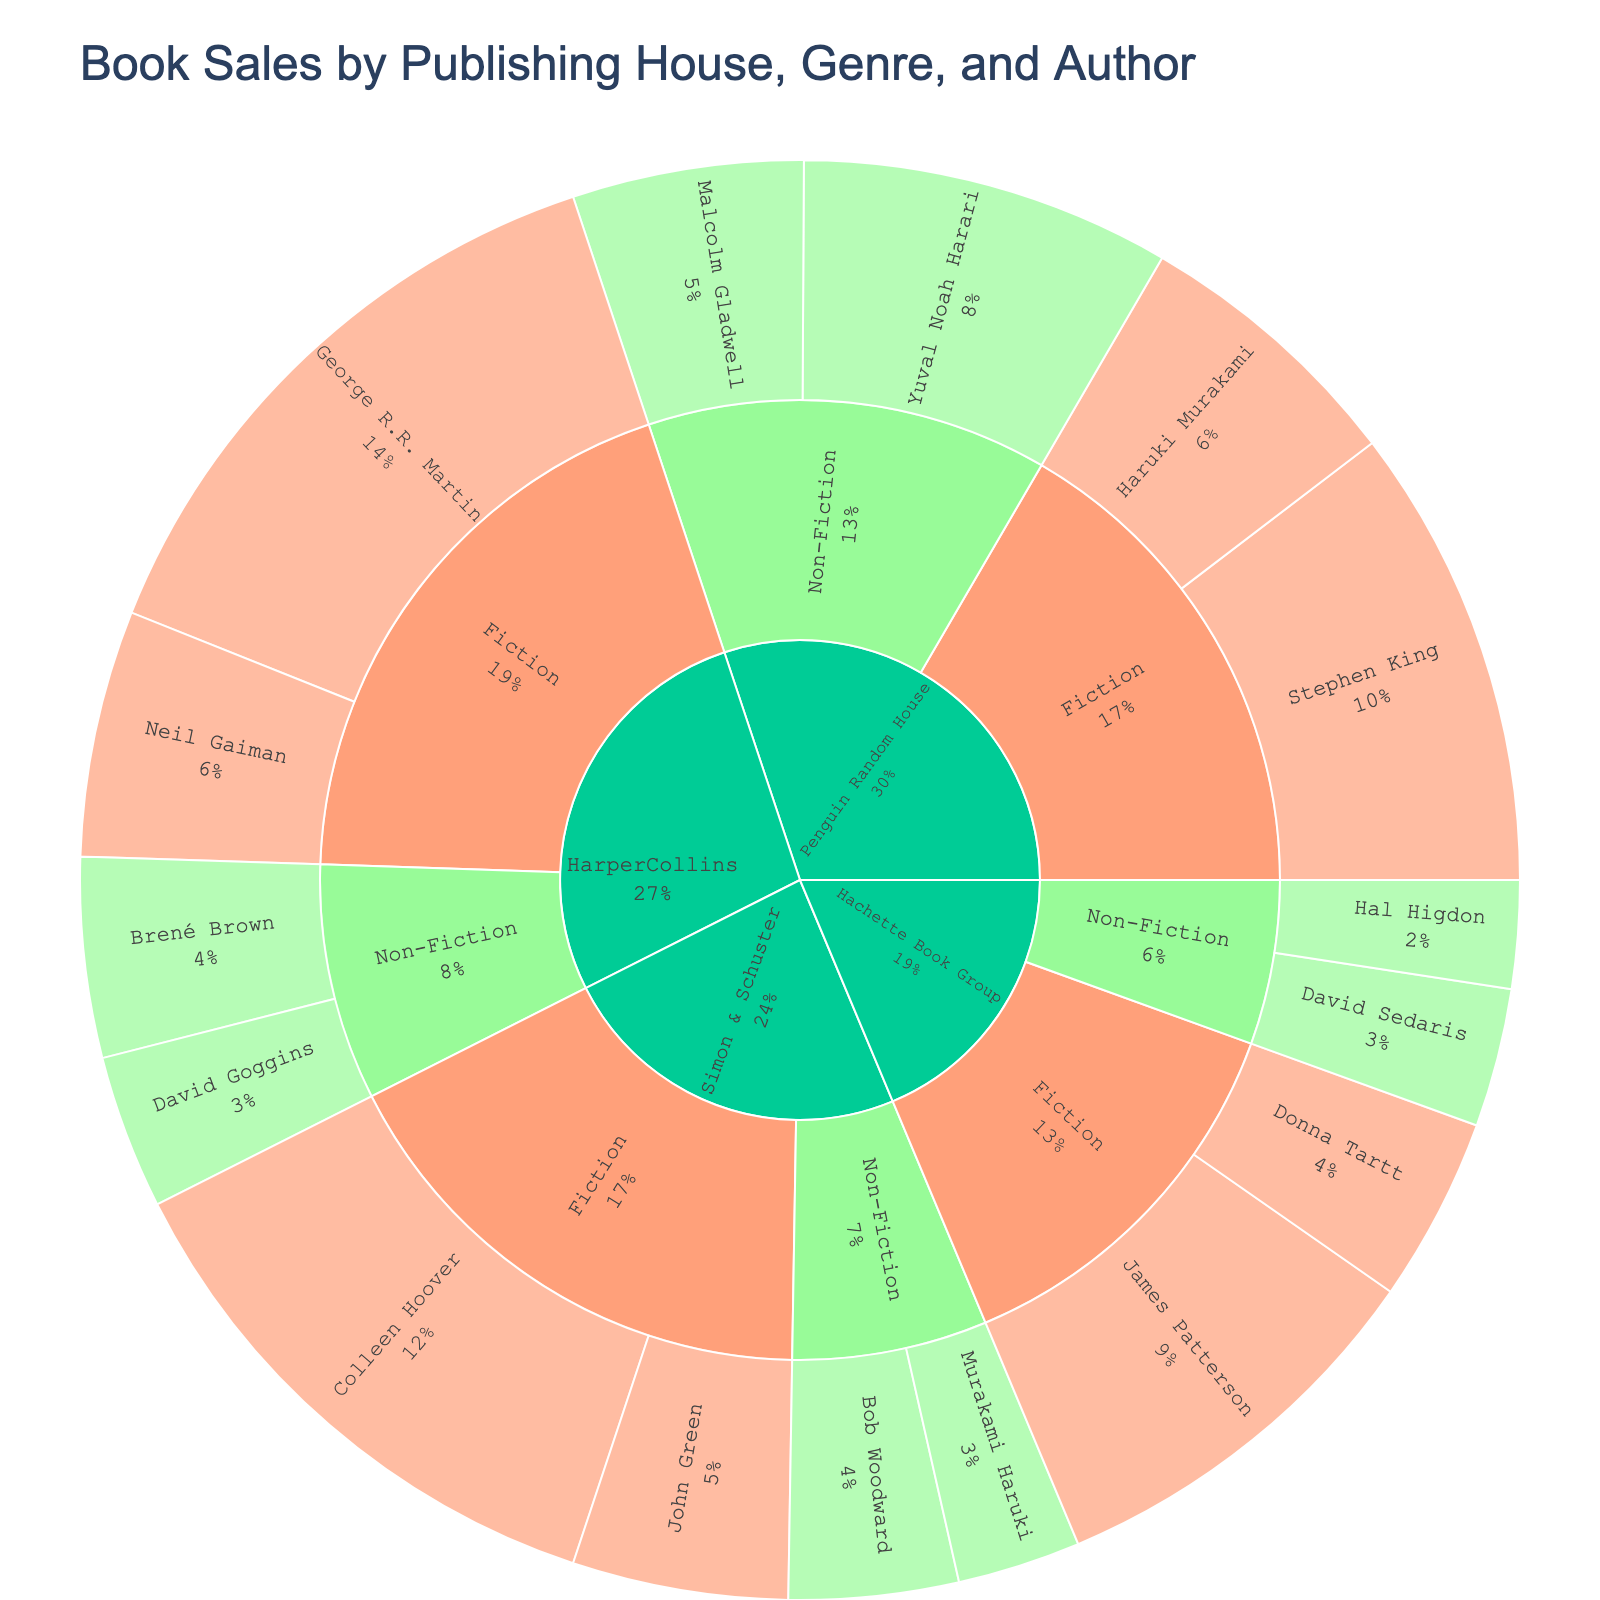**Q1:** What is the overall title of the Sunburst plot? The overall title of the Sunburst plot is directly stated at the top of the figure, indicating the main topic or focus.
Answer: Book Sales by Publishing House, Genre, and Author **Q2:** Which genre has the higher total sales, Fiction or Non-Fiction? To determine the genre with higher total sales, sum the sales of all corresponding authors for both Fiction and Non-Fiction and compare the totals.
Answer: Fiction **Q3:** Which author has the highest book sales? To find the highest selling author, look for the segment representing the author with the largest sales value.
Answer: George R.R. Martin **Q4:** How much is the difference in book sales between Stephen King and Yuval Noah Harari? Find the sales of Stephen King and Yuval Noah Harari, then subtract the smaller value from the larger one to get the difference. Stephen King's sales are 1500000 and Yuval Noah Harari's are 1200000.
Answer: 300000 **Q5:** What are the total sales for Penguin Random House? Sum the sales of all authors under Penguin Random House. Stephen King (1500000) + Haruki Murakami (900000) + Malcolm Gladwell (750000) + Yuval Noah Harari (1200000).
Answer: 4350000 **Q6:** Who is the bestselling Non-Fiction author for HarperCollins? Identify the segments under HarperCollins > Non-Fiction, and determine which author has the highest sales value.
Answer: Brené Brown **Q7:** How do the total Non-Fiction sales compare between Penguin Random House and Hachette Book Group? Sum the Non-Fiction sales for Penguin Random House and Hachette Book Group and compare the two totals. Penguin Random House: Malcolm Gladwell (750000) + Yuval Noah Harari (1200000). Hachette Book Group: David Sedaris (450000) + Hal Higdon (350000).
Answer: Penguin Random House has higher Non-Fiction sales **Q8:** What percentage of total sales does John Green contribute to Simon & Schuster's Fiction category? Calculate the total Fiction sales for Simon & Schuster, then find the percentage contributed by John Green. Colleen Hoover (1800000) + John Green (700000) = 2500000. John Green contributes (700000 / 2500000) * 100%.
Answer: 28% **Q9:** Which publishing house has the lowest total sales in Non-Fiction? Sum the Non-Fiction sales for each publishing house and compare the totals to identify the lowest.
Answer: Hachette Book Group **Q10:** How do the Fiction and Non-Fiction sales for Hachette Book Group compare? Sum the sales for Fiction and Non-Fiction under Hachette Book Group, then compare the two sums. Fiction: James Patterson (1300000) + Donna Tartt (600000). Non-Fiction: David Sedaris (450000) + Hal Higdon (350000).
Answer: Fiction has higher sales 